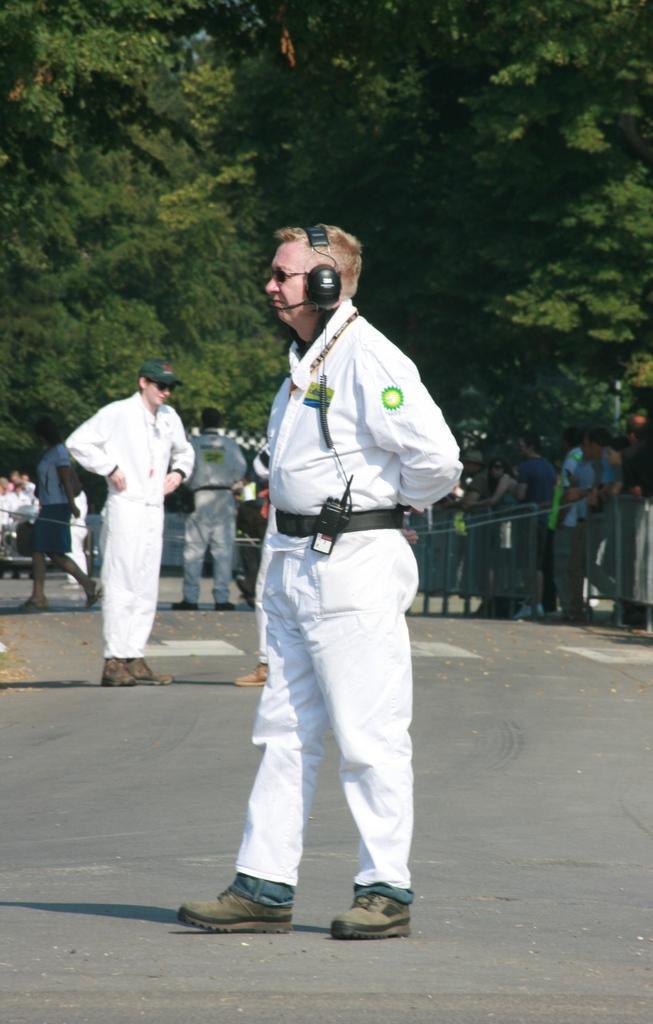Please provide a concise description of this image. In front of the picture, we see a man in the white dress is stunning. He is wearing a headset. At the bottom, we see the road. Behind him, we see a man in the white shirt and the white pant is standing. Behind him, we see the people are standing and we see the ropes and the fence. There are many trees in the background. 